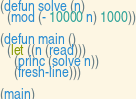Convert code to text. <code><loc_0><loc_0><loc_500><loc_500><_Lisp_>(defun solve (n)
  (mod (- 10000 n) 1000))

(defun main ()
  (let ((n (read)))
    (princ (solve n))
    (fresh-line)))

(main)
</code> 